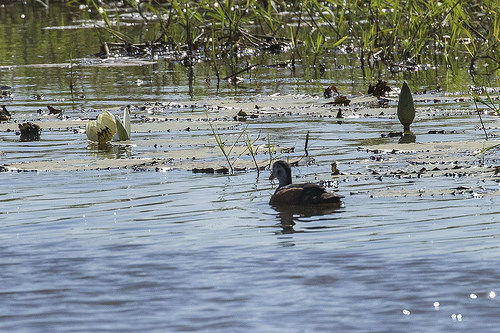<image>
Is there a water lily behind the duck? No. The water lily is not behind the duck. From this viewpoint, the water lily appears to be positioned elsewhere in the scene. 